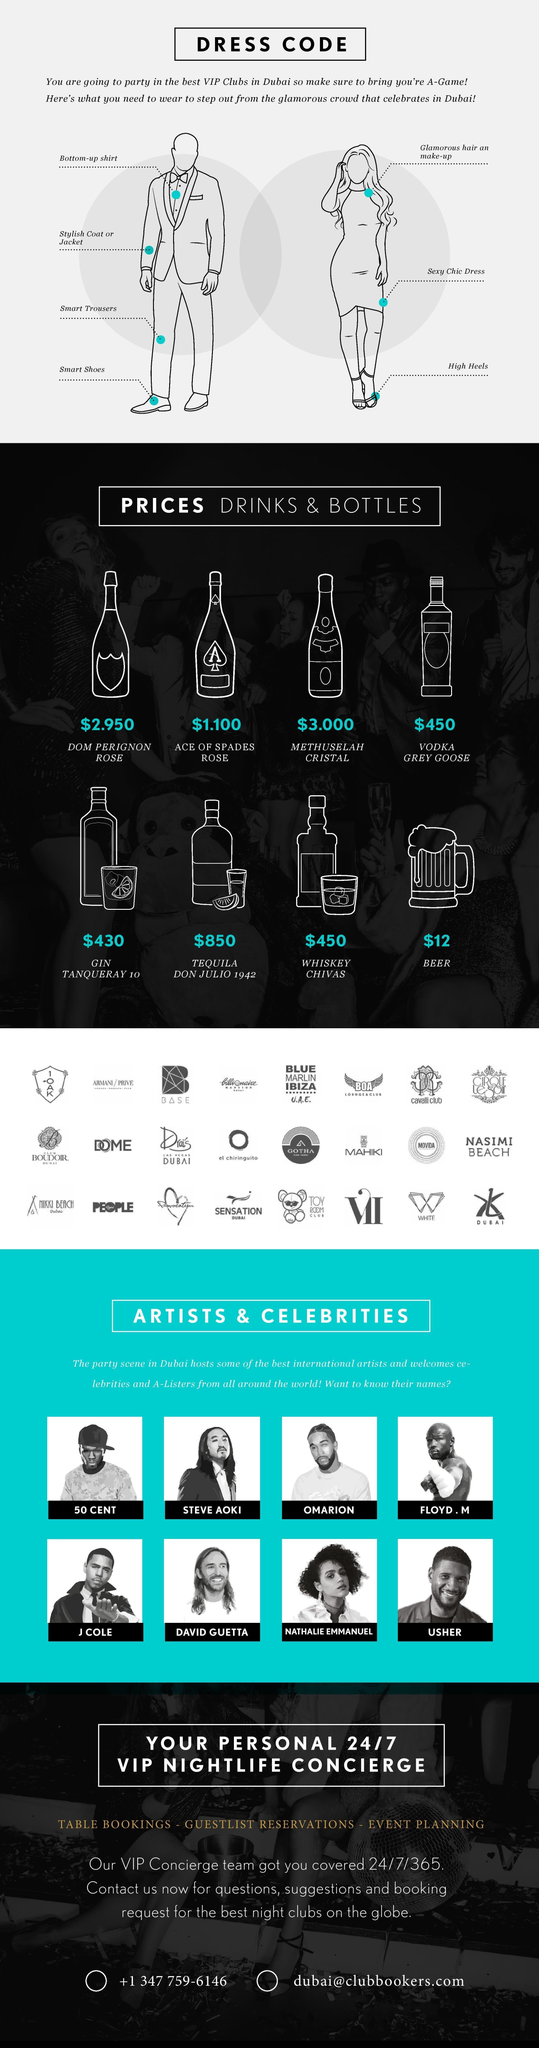Which is the costliest drink you can buy at the VIP club?
Answer the question with a short phrase. Tequila Don Julio 1942 Which artist is placed on the second row and first from the right? Usher Which artist is placed on the first row and third from the left? Omarion How many types of alcoholic drinks are sold in the VIP clubs of Dubai? 8 What is the cost of the cheapest drink in the VIP club? $1.100 Which is the cheapest drink you can buy at the VIP club? Ace Of Spades Rose What is the cost of the most expensive drink in the VIP club? $850 How many drinks are priced below $10? 3 Which drinks are priced at $450? Whiskey Chivas, Vodka Grey Goose Who is the only female artist featured ? Nathalie Emmanuel 